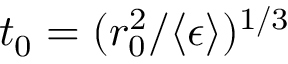<formula> <loc_0><loc_0><loc_500><loc_500>t _ { 0 } = ( r _ { 0 } ^ { 2 } / \langle \epsilon \rangle ) ^ { 1 / 3 }</formula> 